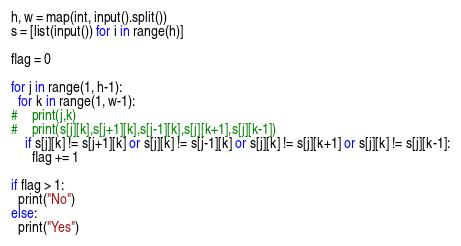<code> <loc_0><loc_0><loc_500><loc_500><_Python_>h, w = map(int, input().split())
s = [list(input()) for i in range(h)]

flag = 0

for j in range(1, h-1):
  for k in range(1, w-1):
#    print(j,k)
#    print(s[j][k],s[j+1][k],s[j-1][k],s[j][k+1],s[j][k-1])
    if s[j][k] != s[j+1][k] or s[j][k] != s[j-1][k] or s[j][k] != s[j][k+1] or s[j][k] != s[j][k-1]:
      flag += 1
      
if flag > 1:
  print("No")
else:
  print("Yes")</code> 